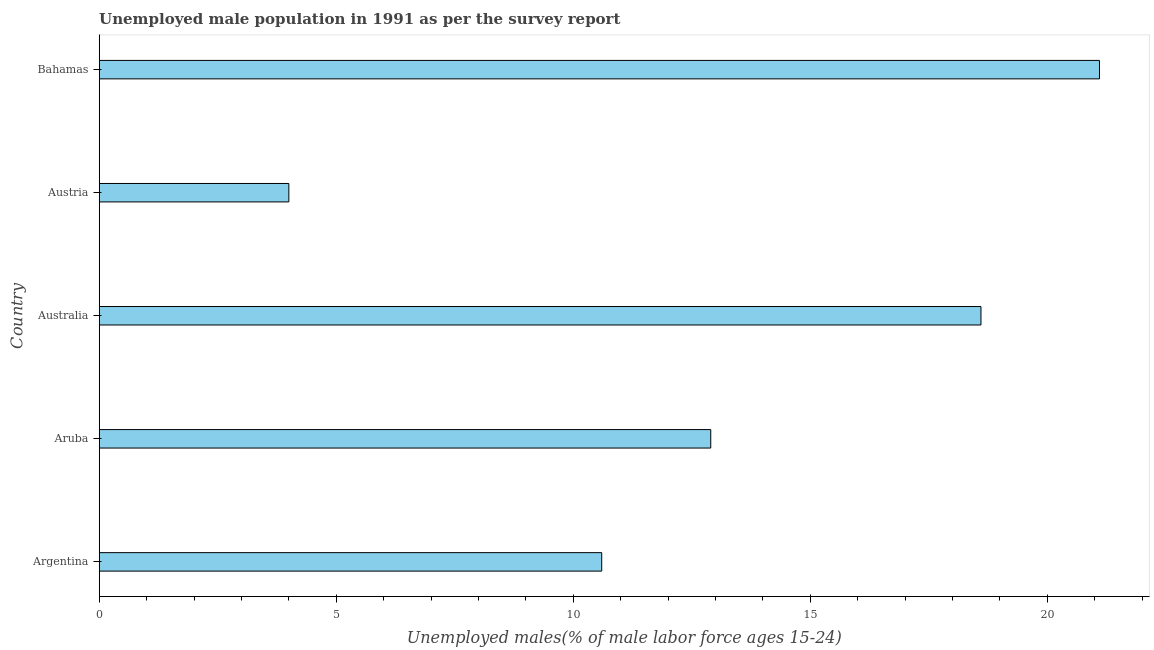Does the graph contain any zero values?
Offer a terse response. No. Does the graph contain grids?
Your answer should be very brief. No. What is the title of the graph?
Give a very brief answer. Unemployed male population in 1991 as per the survey report. What is the label or title of the X-axis?
Give a very brief answer. Unemployed males(% of male labor force ages 15-24). What is the unemployed male youth in Austria?
Make the answer very short. 4. Across all countries, what is the maximum unemployed male youth?
Your response must be concise. 21.1. In which country was the unemployed male youth maximum?
Offer a very short reply. Bahamas. What is the sum of the unemployed male youth?
Keep it short and to the point. 67.2. What is the average unemployed male youth per country?
Your response must be concise. 13.44. What is the median unemployed male youth?
Your response must be concise. 12.9. In how many countries, is the unemployed male youth greater than 12 %?
Your response must be concise. 3. What is the ratio of the unemployed male youth in Aruba to that in Australia?
Your answer should be very brief. 0.69. Is the difference between the unemployed male youth in Argentina and Aruba greater than the difference between any two countries?
Make the answer very short. No. What is the difference between the highest and the second highest unemployed male youth?
Your answer should be compact. 2.5. Is the sum of the unemployed male youth in Australia and Bahamas greater than the maximum unemployed male youth across all countries?
Give a very brief answer. Yes. In how many countries, is the unemployed male youth greater than the average unemployed male youth taken over all countries?
Offer a very short reply. 2. How many bars are there?
Provide a succinct answer. 5. Are all the bars in the graph horizontal?
Give a very brief answer. Yes. Are the values on the major ticks of X-axis written in scientific E-notation?
Give a very brief answer. No. What is the Unemployed males(% of male labor force ages 15-24) in Argentina?
Give a very brief answer. 10.6. What is the Unemployed males(% of male labor force ages 15-24) in Aruba?
Your answer should be very brief. 12.9. What is the Unemployed males(% of male labor force ages 15-24) of Australia?
Give a very brief answer. 18.6. What is the Unemployed males(% of male labor force ages 15-24) in Bahamas?
Your answer should be compact. 21.1. What is the difference between the Unemployed males(% of male labor force ages 15-24) in Argentina and Aruba?
Your response must be concise. -2.3. What is the difference between the Unemployed males(% of male labor force ages 15-24) in Argentina and Bahamas?
Your answer should be compact. -10.5. What is the difference between the Unemployed males(% of male labor force ages 15-24) in Aruba and Austria?
Offer a terse response. 8.9. What is the difference between the Unemployed males(% of male labor force ages 15-24) in Austria and Bahamas?
Offer a very short reply. -17.1. What is the ratio of the Unemployed males(% of male labor force ages 15-24) in Argentina to that in Aruba?
Offer a terse response. 0.82. What is the ratio of the Unemployed males(% of male labor force ages 15-24) in Argentina to that in Australia?
Your response must be concise. 0.57. What is the ratio of the Unemployed males(% of male labor force ages 15-24) in Argentina to that in Austria?
Your answer should be compact. 2.65. What is the ratio of the Unemployed males(% of male labor force ages 15-24) in Argentina to that in Bahamas?
Offer a very short reply. 0.5. What is the ratio of the Unemployed males(% of male labor force ages 15-24) in Aruba to that in Australia?
Your response must be concise. 0.69. What is the ratio of the Unemployed males(% of male labor force ages 15-24) in Aruba to that in Austria?
Your answer should be compact. 3.23. What is the ratio of the Unemployed males(% of male labor force ages 15-24) in Aruba to that in Bahamas?
Provide a succinct answer. 0.61. What is the ratio of the Unemployed males(% of male labor force ages 15-24) in Australia to that in Austria?
Offer a very short reply. 4.65. What is the ratio of the Unemployed males(% of male labor force ages 15-24) in Australia to that in Bahamas?
Offer a very short reply. 0.88. What is the ratio of the Unemployed males(% of male labor force ages 15-24) in Austria to that in Bahamas?
Provide a succinct answer. 0.19. 